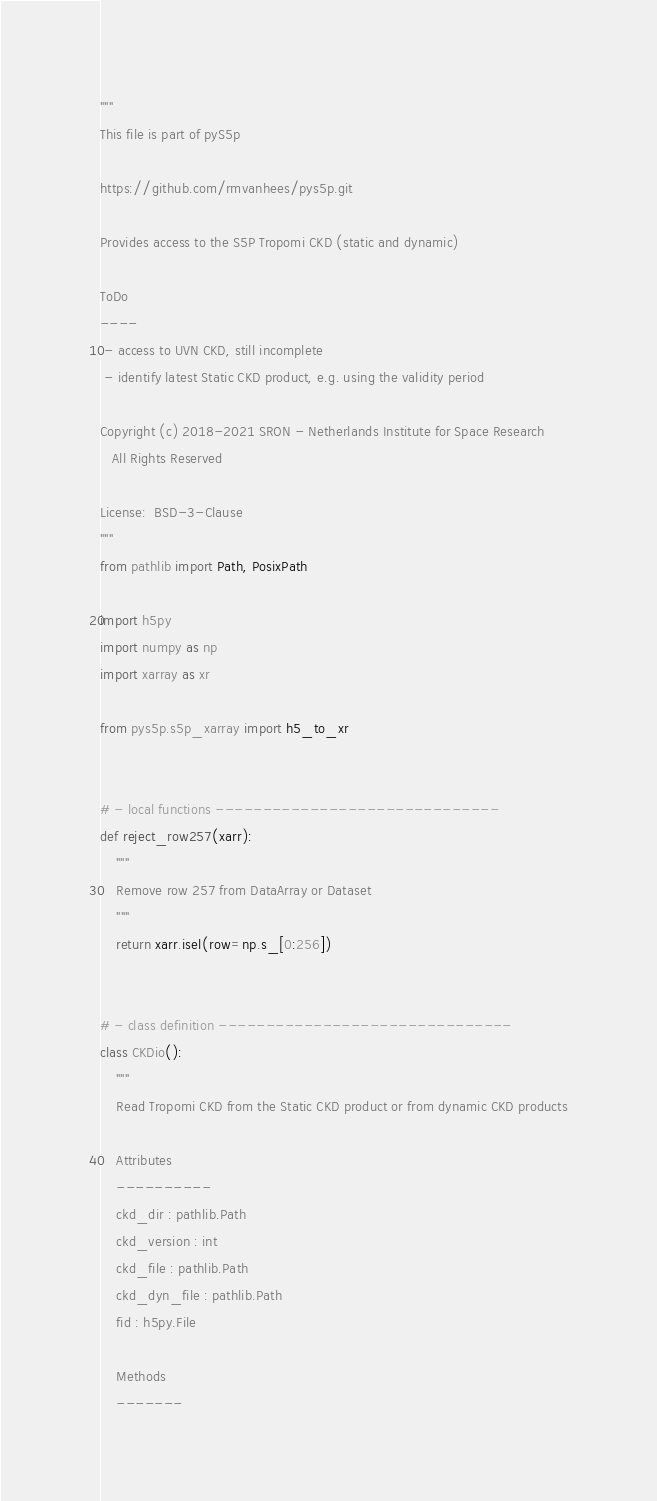Convert code to text. <code><loc_0><loc_0><loc_500><loc_500><_Python_>"""
This file is part of pyS5p

https://github.com/rmvanhees/pys5p.git

Provides access to the S5P Tropomi CKD (static and dynamic)

ToDo
----
 - access to UVN CKD, still incomplete
 - identify latest Static CKD product, e.g. using the validity period

Copyright (c) 2018-2021 SRON - Netherlands Institute for Space Research
   All Rights Reserved

License:  BSD-3-Clause
"""
from pathlib import Path, PosixPath

import h5py
import numpy as np
import xarray as xr

from pys5p.s5p_xarray import h5_to_xr


# - local functions ------------------------------
def reject_row257(xarr):
    """
    Remove row 257 from DataArray or Dataset
    """
    return xarr.isel(row=np.s_[0:256])


# - class definition -------------------------------
class CKDio():
    """
    Read Tropomi CKD from the Static CKD product or from dynamic CKD products

    Attributes
    ----------
    ckd_dir : pathlib.Path
    ckd_version : int
    ckd_file : pathlib.Path
    ckd_dyn_file : pathlib.Path
    fid : h5py.File

    Methods
    -------</code> 